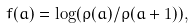Convert formula to latex. <formula><loc_0><loc_0><loc_500><loc_500>f ( a ) = \log ( \rho ( a ) / \rho ( a + 1 ) ) ,</formula> 